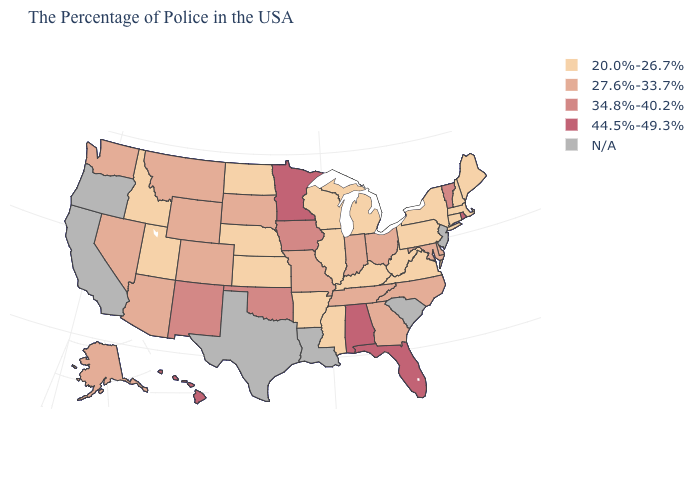Which states have the lowest value in the USA?
Short answer required. Maine, Massachusetts, New Hampshire, Connecticut, New York, Pennsylvania, Virginia, West Virginia, Michigan, Kentucky, Wisconsin, Illinois, Mississippi, Arkansas, Kansas, Nebraska, North Dakota, Utah, Idaho. What is the value of New Jersey?
Be succinct. N/A. What is the value of Virginia?
Give a very brief answer. 20.0%-26.7%. Name the states that have a value in the range 27.6%-33.7%?
Be succinct. Delaware, Maryland, North Carolina, Ohio, Georgia, Indiana, Tennessee, Missouri, South Dakota, Wyoming, Colorado, Montana, Arizona, Nevada, Washington, Alaska. Name the states that have a value in the range 27.6%-33.7%?
Quick response, please. Delaware, Maryland, North Carolina, Ohio, Georgia, Indiana, Tennessee, Missouri, South Dakota, Wyoming, Colorado, Montana, Arizona, Nevada, Washington, Alaska. What is the highest value in the USA?
Short answer required. 44.5%-49.3%. What is the lowest value in the MidWest?
Concise answer only. 20.0%-26.7%. What is the value of South Carolina?
Write a very short answer. N/A. Does the first symbol in the legend represent the smallest category?
Write a very short answer. Yes. What is the lowest value in the West?
Keep it brief. 20.0%-26.7%. Which states hav the highest value in the South?
Be succinct. Florida, Alabama. What is the value of Missouri?
Keep it brief. 27.6%-33.7%. What is the lowest value in the USA?
Concise answer only. 20.0%-26.7%. What is the lowest value in the USA?
Quick response, please. 20.0%-26.7%. 